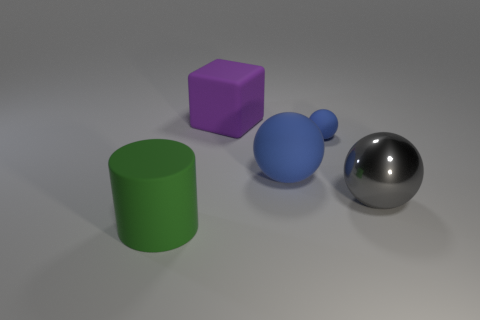There is a thing that is the same color as the big rubber ball; what material is it?
Keep it short and to the point. Rubber. Is there anything else that is the same shape as the purple thing?
Give a very brief answer. No. There is a object that is in front of the large gray ball; is it the same color as the small sphere?
Offer a terse response. No. Is there anything else that is the same material as the green object?
Provide a short and direct response. Yes. What number of other blue objects have the same shape as the big blue thing?
Give a very brief answer. 1. What size is the block that is the same material as the green cylinder?
Give a very brief answer. Large. There is a matte object that is in front of the object that is on the right side of the small matte thing; are there any blue rubber things to the left of it?
Offer a very short reply. No. There is a rubber thing in front of the gray metallic thing; does it have the same size as the large purple object?
Provide a short and direct response. Yes. What number of green matte balls have the same size as the purple object?
Offer a terse response. 0. There is a ball that is the same color as the small matte thing; what size is it?
Offer a very short reply. Large. 